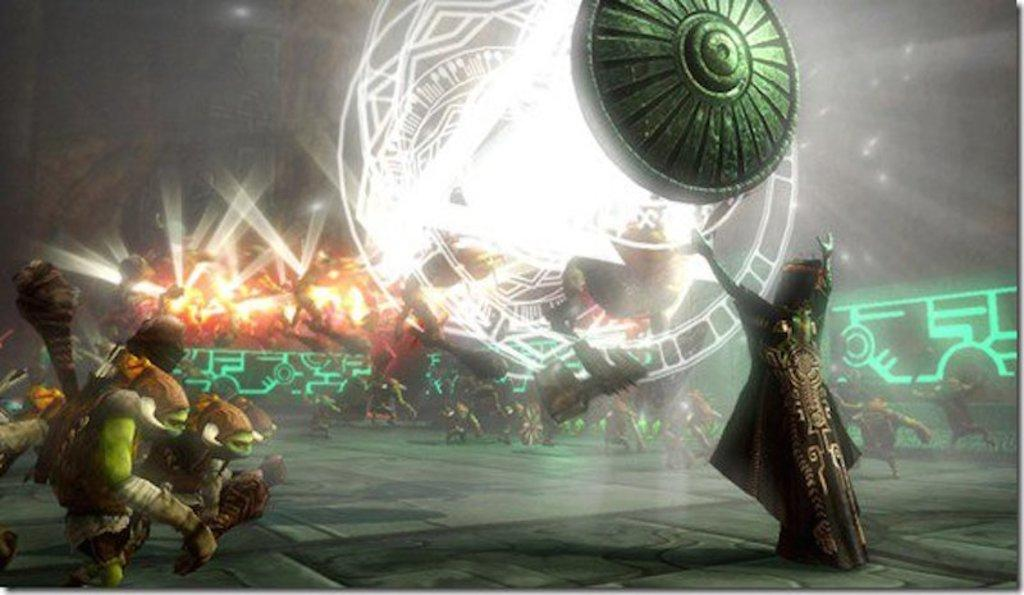What type of pictures are present in the image? There are animated pictures of people in the image. What can be seen in addition to the animated pictures? There are lights visible in the image. How would you describe the background of the image? The background of the image is dark in color. What type of stew is being served in the image? There is no stew present in the image; it features animated pictures of people and lights. Is there a tin can visible in the image? There is no tin can present in the image. 